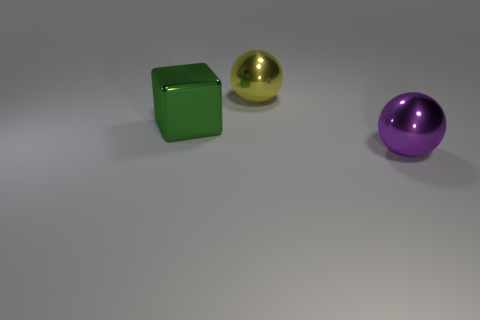Add 1 big purple shiny things. How many objects exist? 4 Subtract 1 balls. How many balls are left? 1 Subtract all balls. How many objects are left? 1 Subtract all cyan balls. Subtract all cyan blocks. How many balls are left? 2 Subtract all yellow metallic things. Subtract all green metallic objects. How many objects are left? 1 Add 1 big purple balls. How many big purple balls are left? 2 Add 3 large blue rubber cylinders. How many large blue rubber cylinders exist? 3 Subtract 0 cyan cubes. How many objects are left? 3 